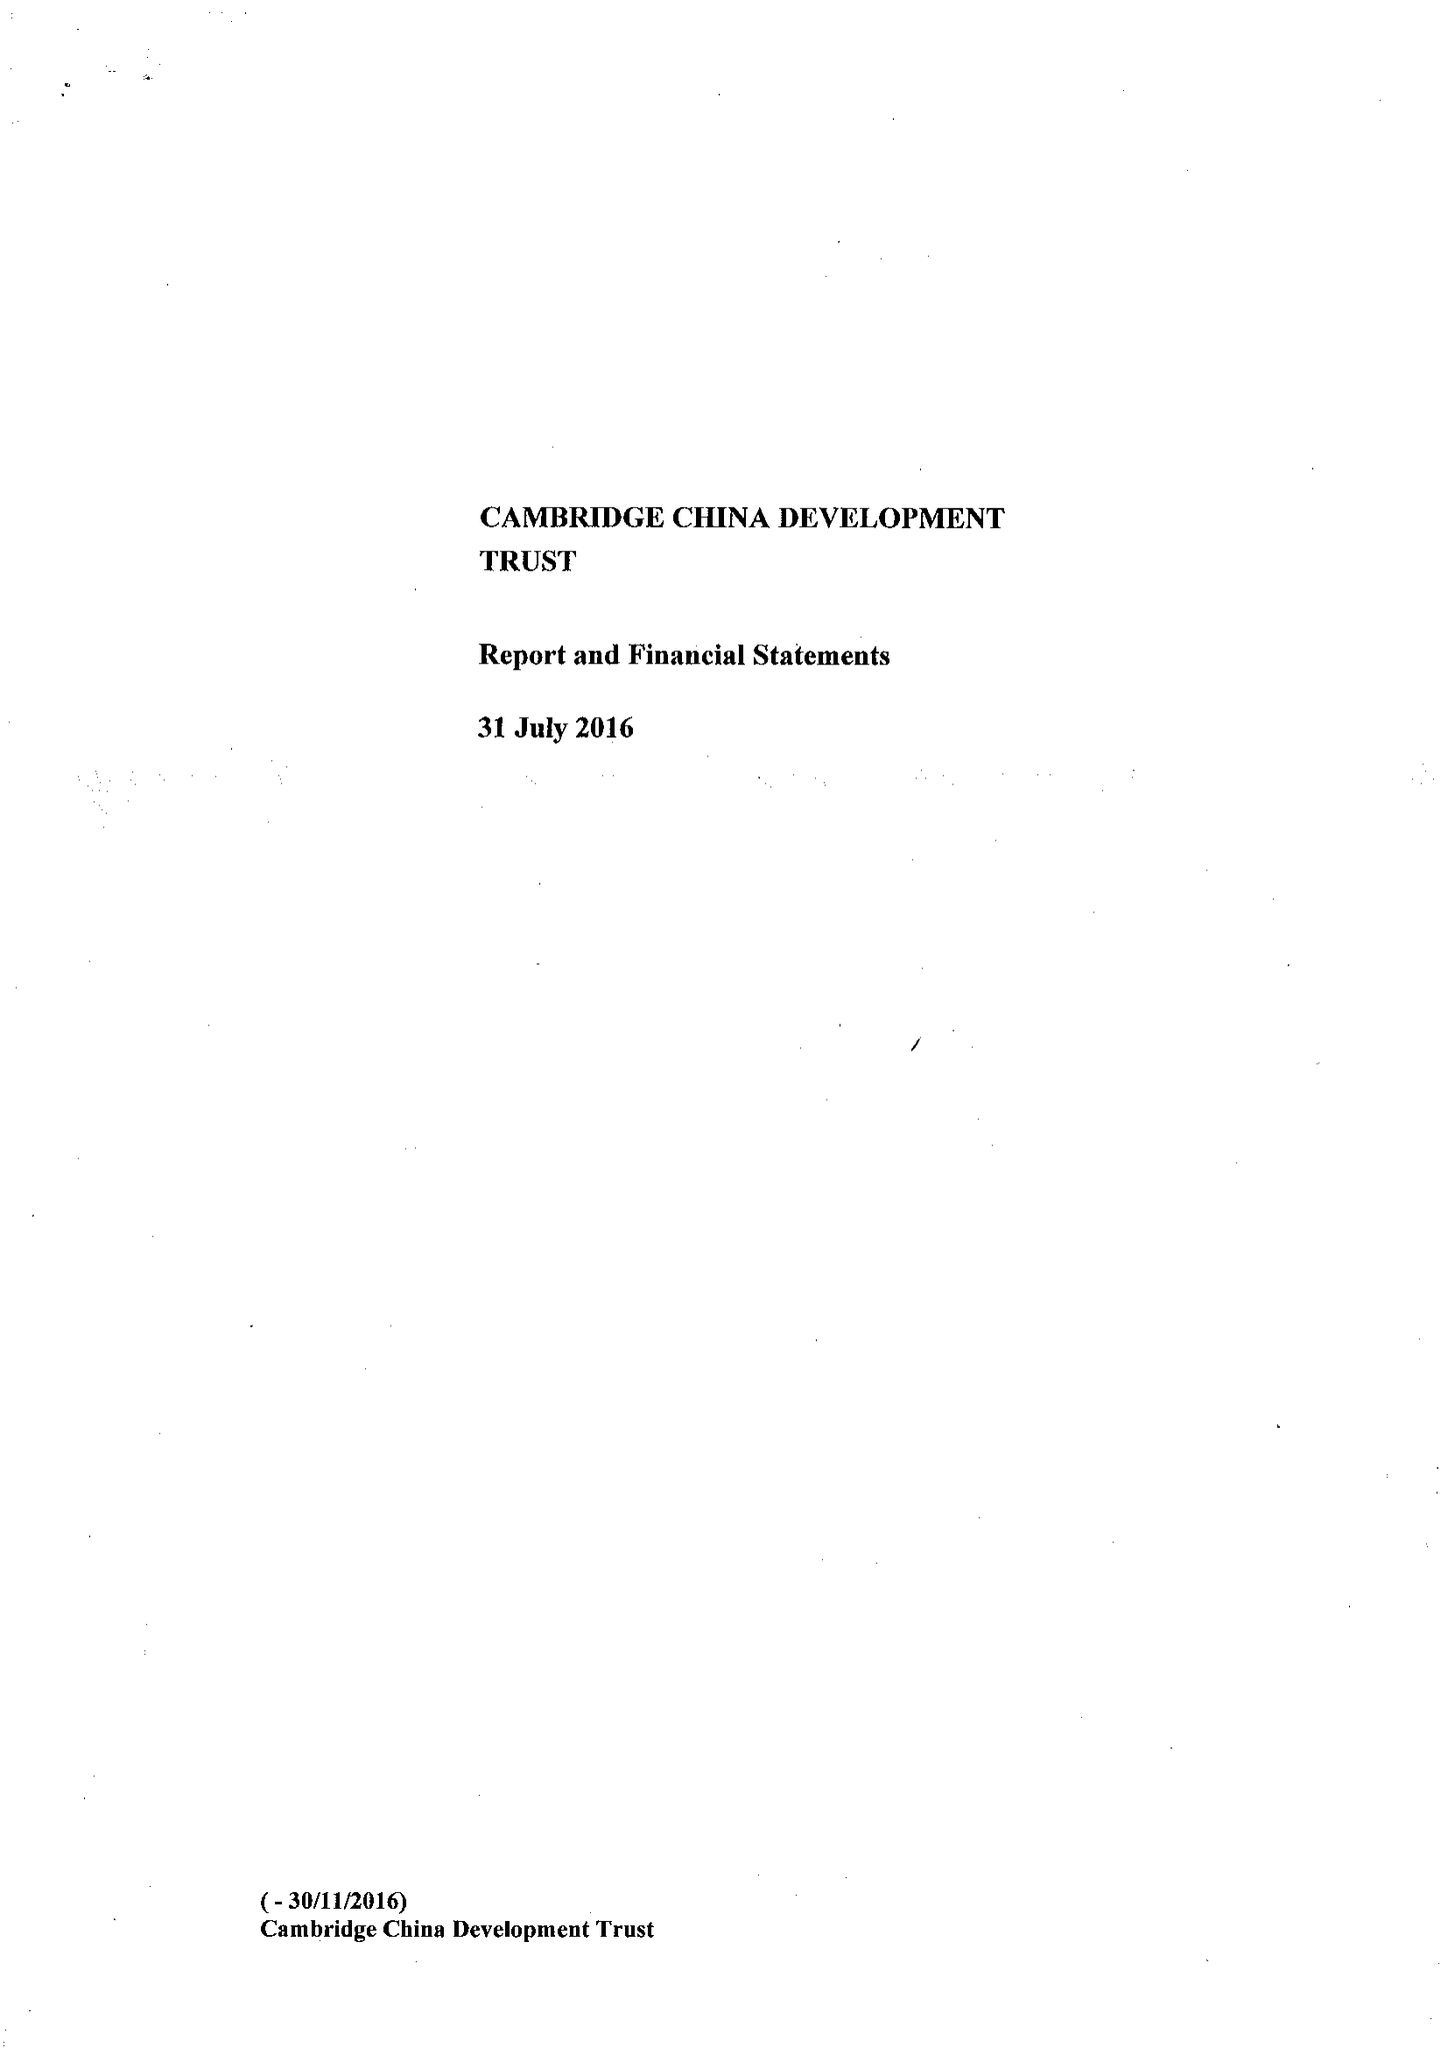What is the value for the spending_annually_in_british_pounds?
Answer the question using a single word or phrase. 492112.00 